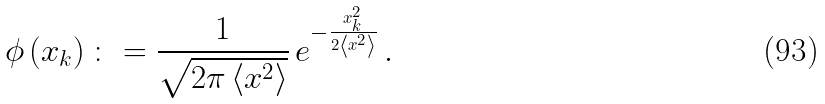Convert formula to latex. <formula><loc_0><loc_0><loc_500><loc_500>\phi \left ( x _ { k } \right ) \colon = \frac { 1 } { \sqrt { 2 \pi \left < x ^ { 2 } \right > } } \, e ^ { - \frac { x _ { k } ^ { 2 } } { 2 \left < x ^ { 2 } \right > } } \, .</formula> 